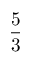Convert formula to latex. <formula><loc_0><loc_0><loc_500><loc_500>\frac { 5 } { 3 }</formula> 